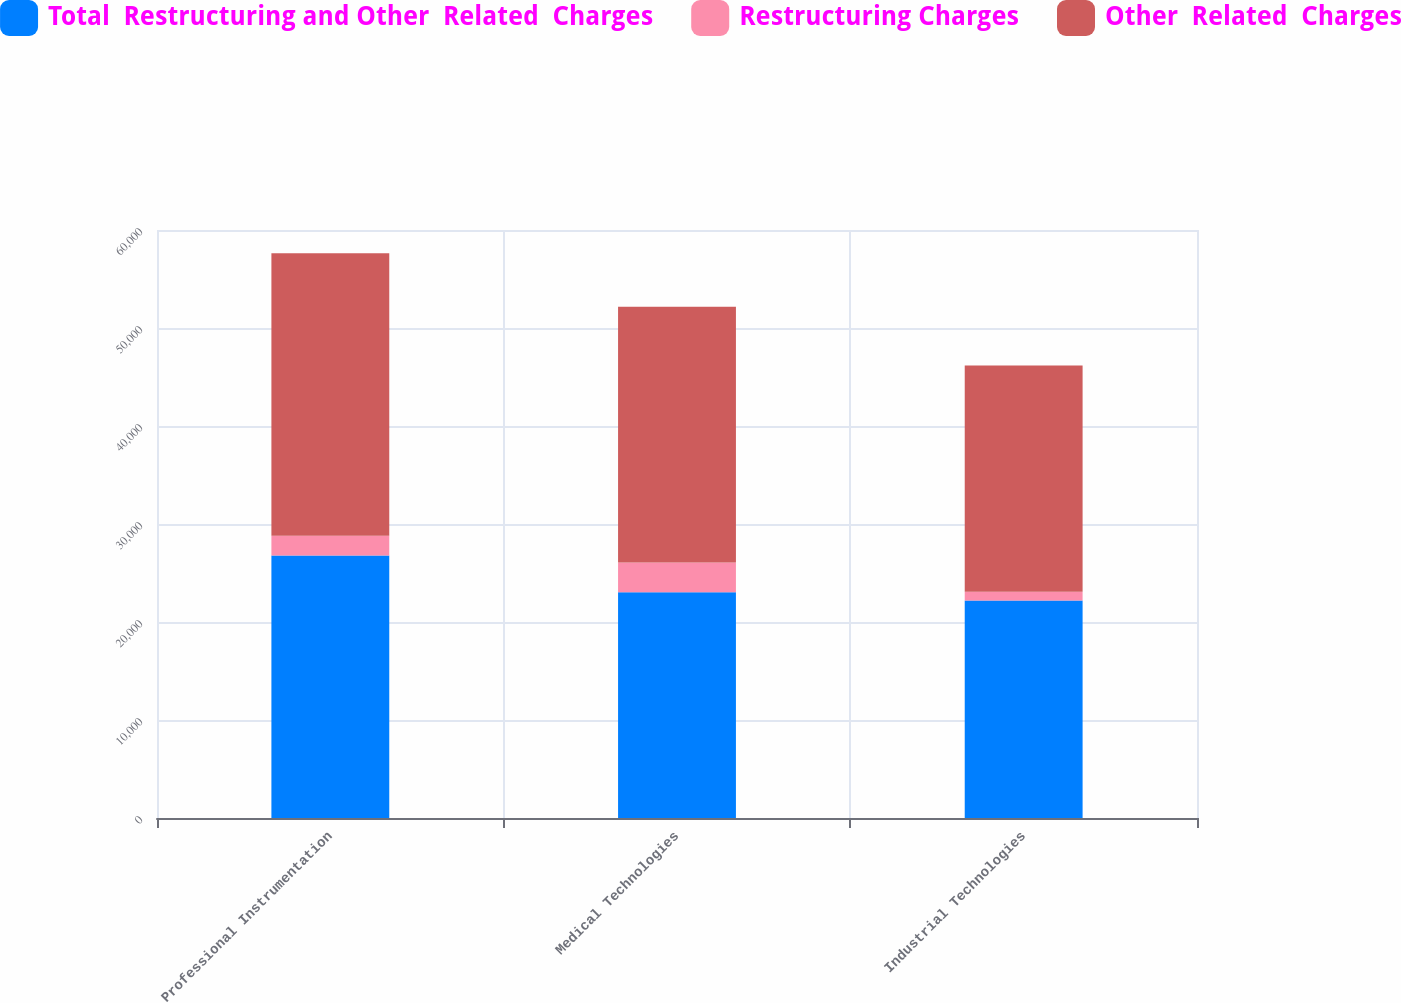<chart> <loc_0><loc_0><loc_500><loc_500><stacked_bar_chart><ecel><fcel>Professional Instrumentation<fcel>Medical Technologies<fcel>Industrial Technologies<nl><fcel>Total  Restructuring and Other  Related  Charges<fcel>26786<fcel>23047<fcel>22199<nl><fcel>Restructuring Charges<fcel>2027<fcel>3034<fcel>894<nl><fcel>Other  Related  Charges<fcel>28813<fcel>26081<fcel>23093<nl></chart> 